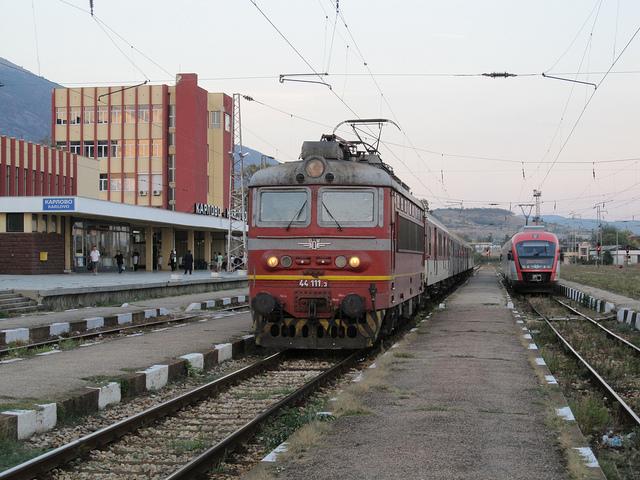Are the train's lights on?
Answer briefly. Yes. What color is the front of the train?
Keep it brief. Red. What time of the day is it?
Concise answer only. Dusk. Is grass growing in the tracks?
Concise answer only. Yes. How many trains are there?
Be succinct. 2. 